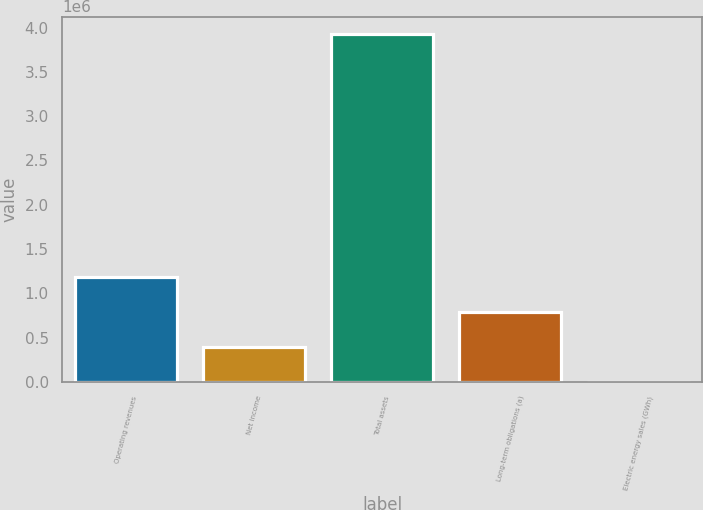<chart> <loc_0><loc_0><loc_500><loc_500><bar_chart><fcel>Operating revenues<fcel>Net income<fcel>Total assets<fcel>Long-term obligations (a)<fcel>Electric energy sales (GWh)<nl><fcel>1.18208e+06<fcel>397617<fcel>3.92771e+06<fcel>789850<fcel>5384<nl></chart> 